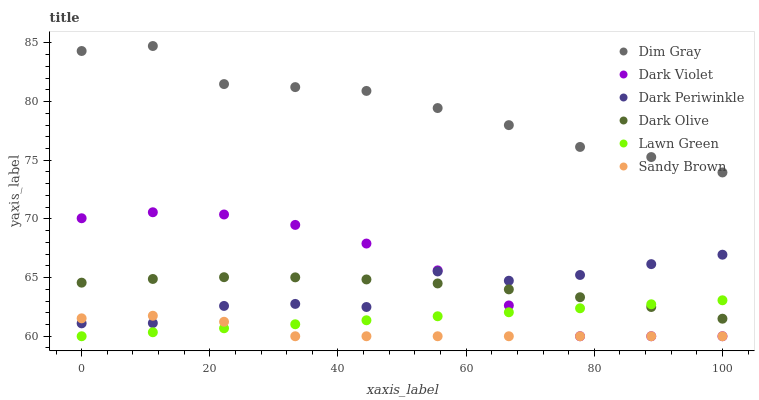Does Sandy Brown have the minimum area under the curve?
Answer yes or no. Yes. Does Dim Gray have the maximum area under the curve?
Answer yes or no. Yes. Does Dark Olive have the minimum area under the curve?
Answer yes or no. No. Does Dark Olive have the maximum area under the curve?
Answer yes or no. No. Is Lawn Green the smoothest?
Answer yes or no. Yes. Is Dark Periwinkle the roughest?
Answer yes or no. Yes. Is Dim Gray the smoothest?
Answer yes or no. No. Is Dim Gray the roughest?
Answer yes or no. No. Does Lawn Green have the lowest value?
Answer yes or no. Yes. Does Dark Olive have the lowest value?
Answer yes or no. No. Does Dim Gray have the highest value?
Answer yes or no. Yes. Does Dark Olive have the highest value?
Answer yes or no. No. Is Dark Periwinkle less than Dim Gray?
Answer yes or no. Yes. Is Dim Gray greater than Dark Periwinkle?
Answer yes or no. Yes. Does Dark Violet intersect Lawn Green?
Answer yes or no. Yes. Is Dark Violet less than Lawn Green?
Answer yes or no. No. Is Dark Violet greater than Lawn Green?
Answer yes or no. No. Does Dark Periwinkle intersect Dim Gray?
Answer yes or no. No. 